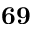Convert formula to latex. <formula><loc_0><loc_0><loc_500><loc_500>6 9</formula> 